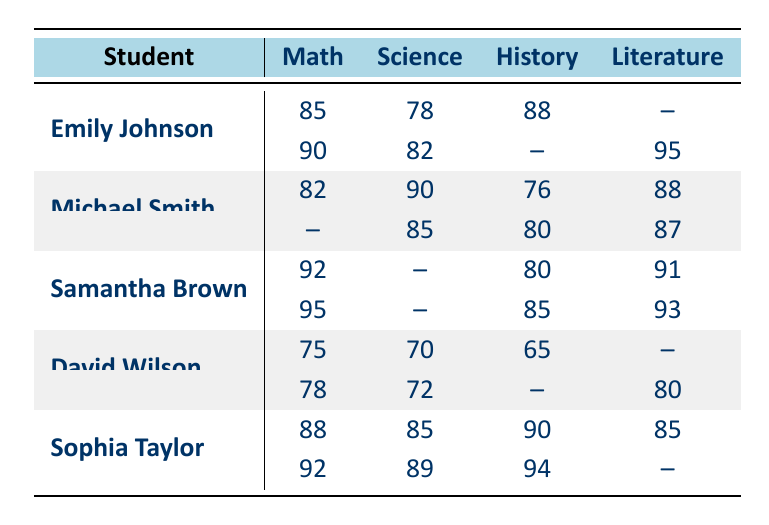What is the final score of Emily Johnson in literature? The table shows Emily Johnson's scores for literature; the midterm score is missing (indicated by --), but the final score is 95.
Answer: 95 Which student had the highest midterm score in math? Emily Johnson scored 85 in math, Michael Smith scored 82, Samantha Brown scored 92, David Wilson scored 75, and Sophia Taylor scored 88. Therefore, Samantha Brown had the highest at 92.
Answer: Samantha Brown What was Michael Smith's overall performance in history? In history, Michael had a midterm score of 76 and a final score of 80. Therefore, his overall performance in history consists of these two scores without any missing data.
Answer: Midterm: 76, Final: 80 Did David Wilson achieve a final score in history? The table indicates that David Wilson's final score in history is missing (indicated by --). Hence, the answer is no, he did not achieve a final score.
Answer: No What is the average midterm score in math for all students? To find the average, sum the midterm scores for math: 85 (Emily) + 82 (Michael) + 92 (Samantha) + 75 (David) + 88 (Sophia) = 422. There are 5 students, so the average is 422/5 = 84.4.
Answer: 84.4 Who had the lowest science midterm score? Looking at the science midterm scores: 78 (Emily), 90 (Michael), 70 (David), and a missing score from Samantha. David's score of 70 is the lowest.
Answer: David Wilson What are the combined final scores for Sophia Taylor across all subjects? Sophia's final scores are 92 (math), missing score (science), 94 (history), and missing score (literature). Adding up the known scores: 92 + 94 = 186.
Answer: 186 Is there any student who scored above 90 in both midterm and final in math? Samantha Brown scored 92 in the midterm and 95 in the final; no other student scored above 90 in both. Therefore, the answer is yes.
Answer: Yes What is the range of final scores in history? The final scores in history are 80 (Michael), missing (David), 85 (Samantha), and missing (Emily, Sophia). The known scores are 80 and 85, giving a range of 85 - 80 = 5.
Answer: 5 How many subjects did Samantha Brown score above 90? Samantha scored 92 (midterm math), 95 (final math), 85 (final history), and 93 (final literature). She scored above 90 in math both times and once in literature, totaling 3 subjects.
Answer: 3 